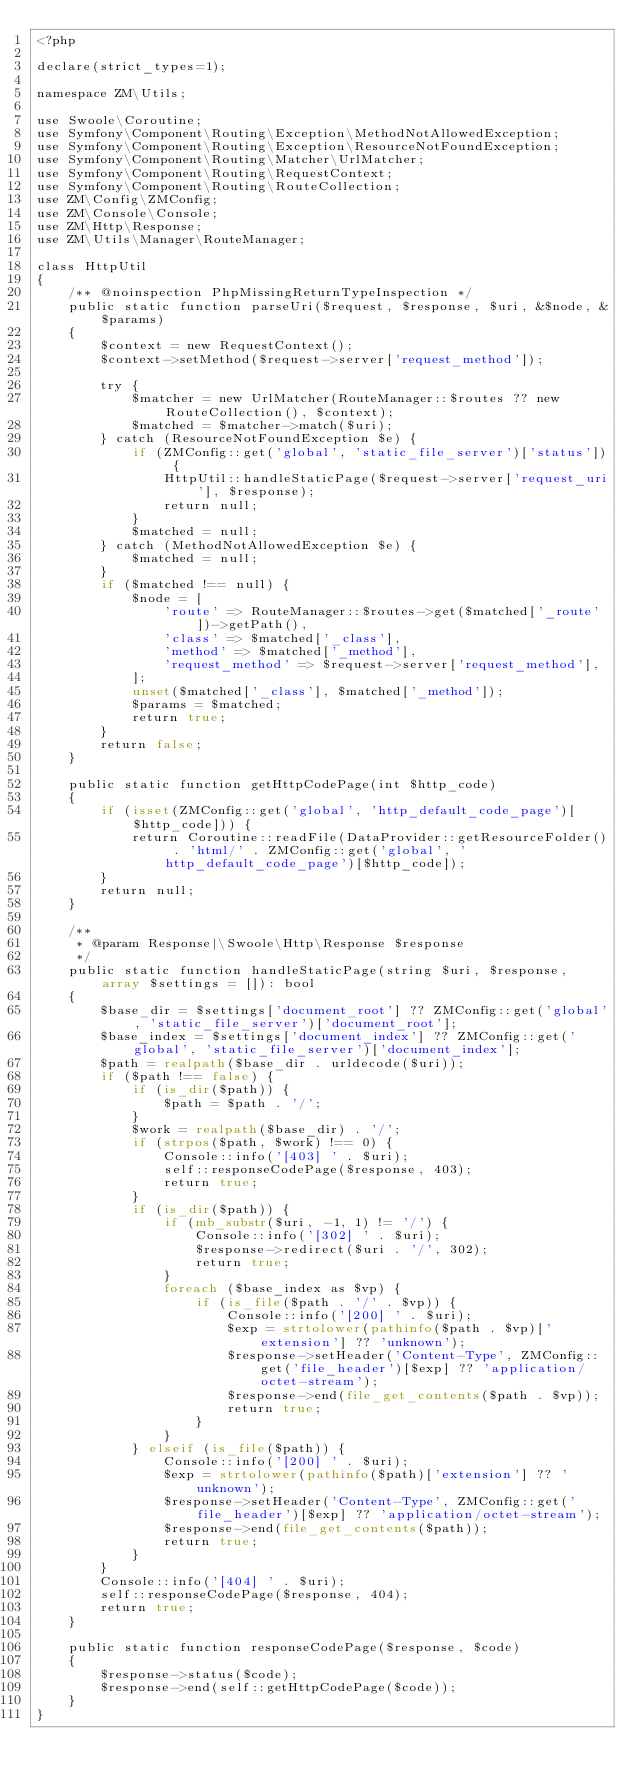Convert code to text. <code><loc_0><loc_0><loc_500><loc_500><_PHP_><?php

declare(strict_types=1);

namespace ZM\Utils;

use Swoole\Coroutine;
use Symfony\Component\Routing\Exception\MethodNotAllowedException;
use Symfony\Component\Routing\Exception\ResourceNotFoundException;
use Symfony\Component\Routing\Matcher\UrlMatcher;
use Symfony\Component\Routing\RequestContext;
use Symfony\Component\Routing\RouteCollection;
use ZM\Config\ZMConfig;
use ZM\Console\Console;
use ZM\Http\Response;
use ZM\Utils\Manager\RouteManager;

class HttpUtil
{
    /** @noinspection PhpMissingReturnTypeInspection */
    public static function parseUri($request, $response, $uri, &$node, &$params)
    {
        $context = new RequestContext();
        $context->setMethod($request->server['request_method']);

        try {
            $matcher = new UrlMatcher(RouteManager::$routes ?? new RouteCollection(), $context);
            $matched = $matcher->match($uri);
        } catch (ResourceNotFoundException $e) {
            if (ZMConfig::get('global', 'static_file_server')['status']) {
                HttpUtil::handleStaticPage($request->server['request_uri'], $response);
                return null;
            }
            $matched = null;
        } catch (MethodNotAllowedException $e) {
            $matched = null;
        }
        if ($matched !== null) {
            $node = [
                'route' => RouteManager::$routes->get($matched['_route'])->getPath(),
                'class' => $matched['_class'],
                'method' => $matched['_method'],
                'request_method' => $request->server['request_method'],
            ];
            unset($matched['_class'], $matched['_method']);
            $params = $matched;
            return true;
        }
        return false;
    }

    public static function getHttpCodePage(int $http_code)
    {
        if (isset(ZMConfig::get('global', 'http_default_code_page')[$http_code])) {
            return Coroutine::readFile(DataProvider::getResourceFolder() . 'html/' . ZMConfig::get('global', 'http_default_code_page')[$http_code]);
        }
        return null;
    }

    /**
     * @param Response|\Swoole\Http\Response $response
     */
    public static function handleStaticPage(string $uri, $response, array $settings = []): bool
    {
        $base_dir = $settings['document_root'] ?? ZMConfig::get('global', 'static_file_server')['document_root'];
        $base_index = $settings['document_index'] ?? ZMConfig::get('global', 'static_file_server')['document_index'];
        $path = realpath($base_dir . urldecode($uri));
        if ($path !== false) {
            if (is_dir($path)) {
                $path = $path . '/';
            }
            $work = realpath($base_dir) . '/';
            if (strpos($path, $work) !== 0) {
                Console::info('[403] ' . $uri);
                self::responseCodePage($response, 403);
                return true;
            }
            if (is_dir($path)) {
                if (mb_substr($uri, -1, 1) != '/') {
                    Console::info('[302] ' . $uri);
                    $response->redirect($uri . '/', 302);
                    return true;
                }
                foreach ($base_index as $vp) {
                    if (is_file($path . '/' . $vp)) {
                        Console::info('[200] ' . $uri);
                        $exp = strtolower(pathinfo($path . $vp)['extension'] ?? 'unknown');
                        $response->setHeader('Content-Type', ZMConfig::get('file_header')[$exp] ?? 'application/octet-stream');
                        $response->end(file_get_contents($path . $vp));
                        return true;
                    }
                }
            } elseif (is_file($path)) {
                Console::info('[200] ' . $uri);
                $exp = strtolower(pathinfo($path)['extension'] ?? 'unknown');
                $response->setHeader('Content-Type', ZMConfig::get('file_header')[$exp] ?? 'application/octet-stream');
                $response->end(file_get_contents($path));
                return true;
            }
        }
        Console::info('[404] ' . $uri);
        self::responseCodePage($response, 404);
        return true;
    }

    public static function responseCodePage($response, $code)
    {
        $response->status($code);
        $response->end(self::getHttpCodePage($code));
    }
}
</code> 